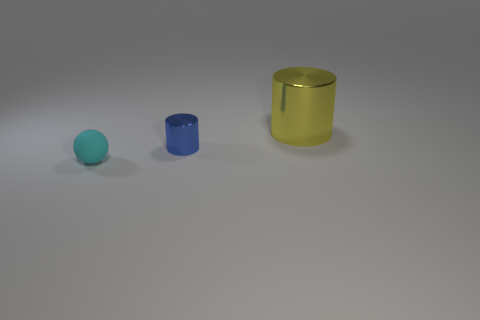Add 1 small cyan matte objects. How many objects exist? 4 Subtract all yellow cylinders. How many cylinders are left? 1 Subtract all cylinders. How many objects are left? 1 Add 1 large shiny cylinders. How many large shiny cylinders are left? 2 Add 3 cyan objects. How many cyan objects exist? 4 Subtract 0 cyan cubes. How many objects are left? 3 Subtract all green cylinders. Subtract all purple balls. How many cylinders are left? 2 Subtract all small purple shiny blocks. Subtract all large shiny things. How many objects are left? 2 